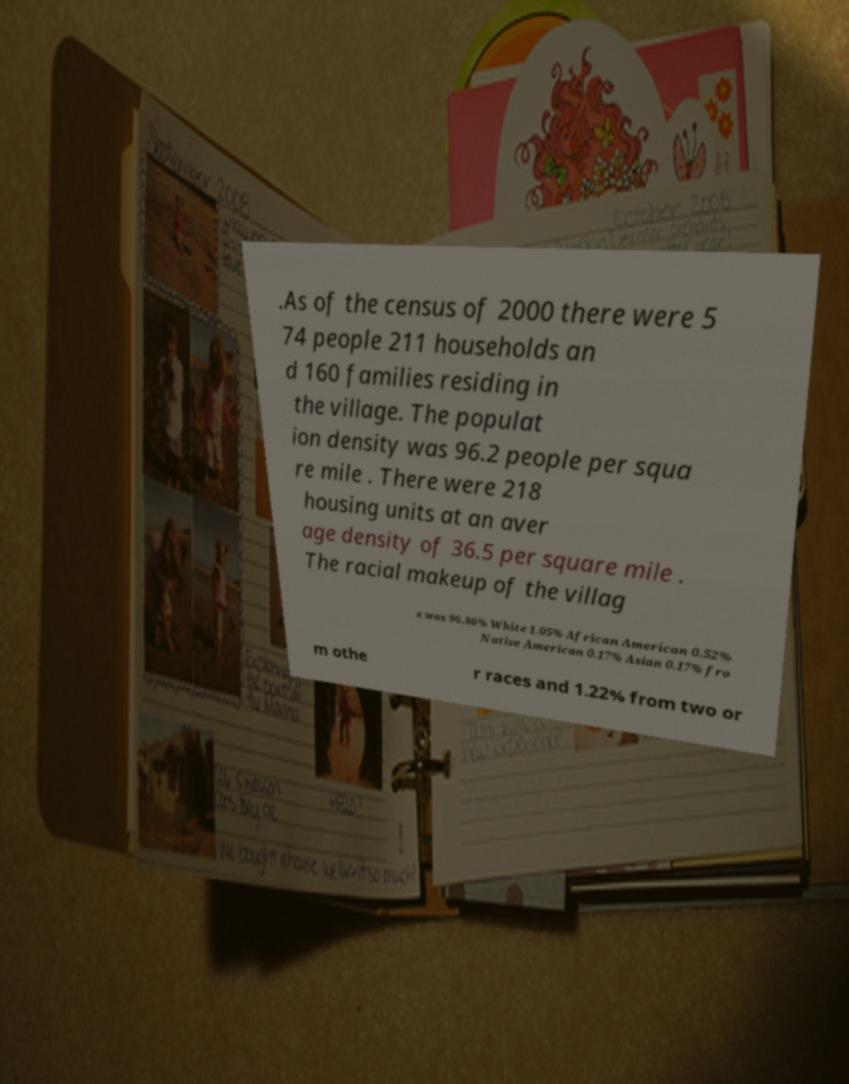Please read and relay the text visible in this image. What does it say? .As of the census of 2000 there were 5 74 people 211 households an d 160 families residing in the village. The populat ion density was 96.2 people per squa re mile . There were 218 housing units at an aver age density of 36.5 per square mile . The racial makeup of the villag e was 96.86% White 1.05% African American 0.52% Native American 0.17% Asian 0.17% fro m othe r races and 1.22% from two or 